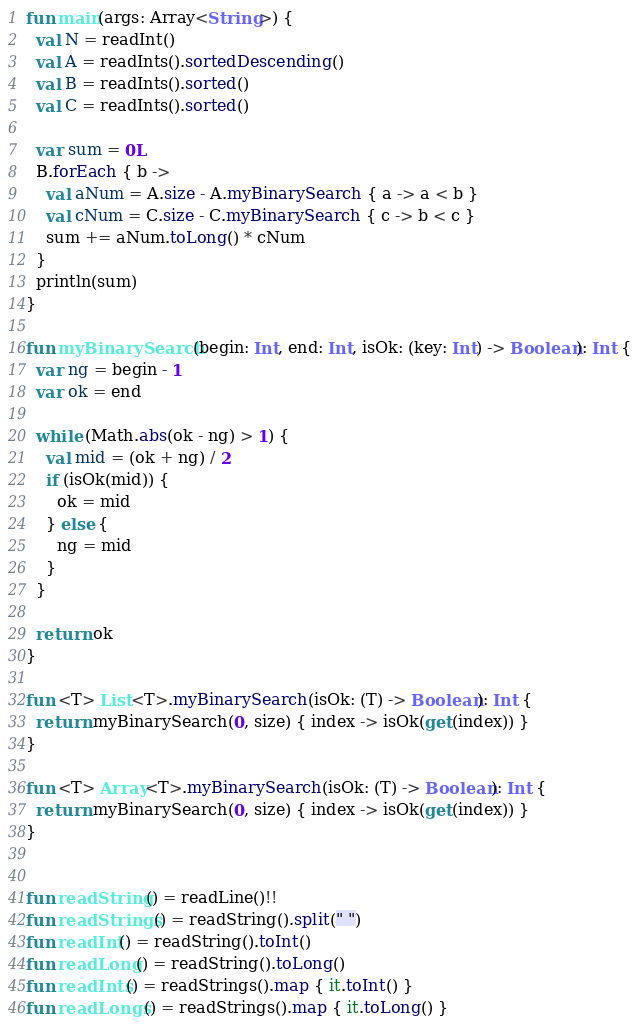Convert code to text. <code><loc_0><loc_0><loc_500><loc_500><_Kotlin_>fun main(args: Array<String>) {
  val N = readInt()
  val A = readInts().sortedDescending()
  val B = readInts().sorted()
  val C = readInts().sorted()

  var sum = 0L
  B.forEach { b ->
    val aNum = A.size - A.myBinarySearch { a -> a < b }
    val cNum = C.size - C.myBinarySearch { c -> b < c }
    sum += aNum.toLong() * cNum
  }
  println(sum)
}

fun myBinarySearch(begin: Int, end: Int, isOk: (key: Int) -> Boolean): Int {
  var ng = begin - 1
  var ok = end

  while (Math.abs(ok - ng) > 1) {
    val mid = (ok + ng) / 2
    if (isOk(mid)) {
      ok = mid
    } else {
      ng = mid
    }
  }

  return ok
}

fun <T> List<T>.myBinarySearch(isOk: (T) -> Boolean): Int {
  return myBinarySearch(0, size) { index -> isOk(get(index)) }
}

fun <T> Array<T>.myBinarySearch(isOk: (T) -> Boolean): Int {
  return myBinarySearch(0, size) { index -> isOk(get(index)) }
}


fun readString() = readLine()!!
fun readStrings() = readString().split(" ")
fun readInt() = readString().toInt()
fun readLong() = readString().toLong()
fun readInts() = readStrings().map { it.toInt() }
fun readLongs() = readStrings().map { it.toLong() }
</code> 